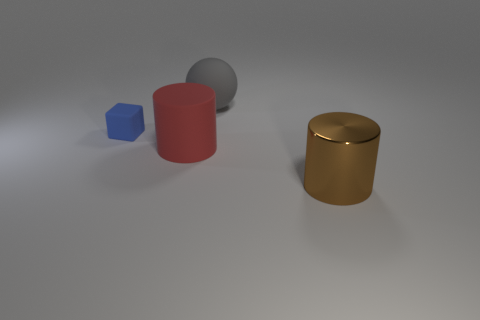Subtract all red cylinders. Subtract all blue spheres. How many cylinders are left? 1 Subtract all cyan cubes. How many brown cylinders are left? 1 Subtract all big gray matte objects. Subtract all brown metallic cylinders. How many objects are left? 2 Add 3 red objects. How many red objects are left? 4 Add 1 big matte objects. How many big matte objects exist? 3 Add 4 big gray rubber things. How many objects exist? 8 Subtract all brown cylinders. How many cylinders are left? 1 Subtract 0 cyan blocks. How many objects are left? 4 Subtract all cubes. How many objects are left? 3 Subtract 1 cubes. How many cubes are left? 0 